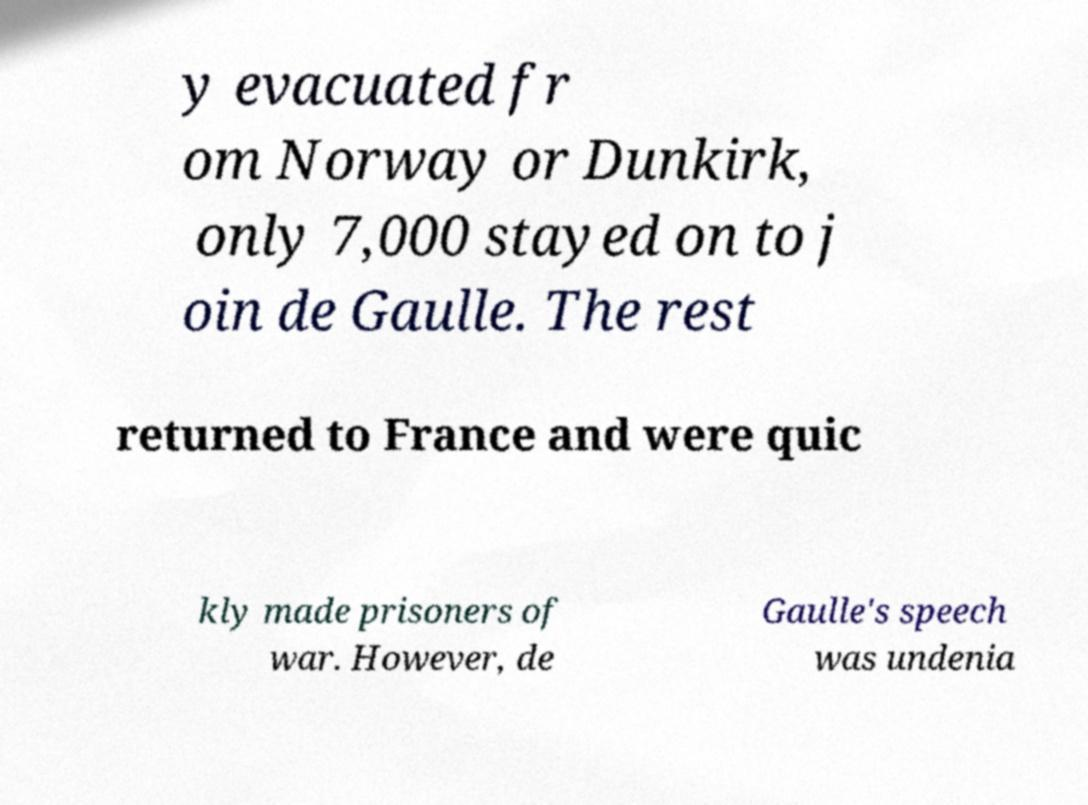For documentation purposes, I need the text within this image transcribed. Could you provide that? y evacuated fr om Norway or Dunkirk, only 7,000 stayed on to j oin de Gaulle. The rest returned to France and were quic kly made prisoners of war. However, de Gaulle's speech was undenia 